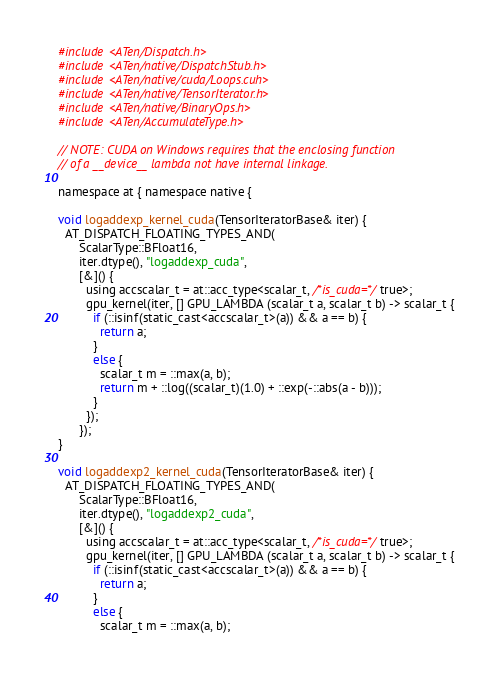<code> <loc_0><loc_0><loc_500><loc_500><_Cuda_>#include <ATen/Dispatch.h>
#include <ATen/native/DispatchStub.h>
#include <ATen/native/cuda/Loops.cuh>
#include <ATen/native/TensorIterator.h>
#include <ATen/native/BinaryOps.h>
#include <ATen/AccumulateType.h>

// NOTE: CUDA on Windows requires that the enclosing function
// of a __device__ lambda not have internal linkage.

namespace at { namespace native {

void logaddexp_kernel_cuda(TensorIteratorBase& iter) {
  AT_DISPATCH_FLOATING_TYPES_AND(
      ScalarType::BFloat16,
      iter.dtype(), "logaddexp_cuda",
      [&]() {
        using accscalar_t = at::acc_type<scalar_t, /*is_cuda=*/true>;
        gpu_kernel(iter, [] GPU_LAMBDA (scalar_t a, scalar_t b) -> scalar_t {
          if (::isinf(static_cast<accscalar_t>(a)) && a == b) {
            return a;
          }
          else {
            scalar_t m = ::max(a, b);
            return m + ::log((scalar_t)(1.0) + ::exp(-::abs(a - b)));
          }
        });
      });
}

void logaddexp2_kernel_cuda(TensorIteratorBase& iter) {
  AT_DISPATCH_FLOATING_TYPES_AND(
      ScalarType::BFloat16,
      iter.dtype(), "logaddexp2_cuda",
      [&]() {
        using accscalar_t = at::acc_type<scalar_t, /*is_cuda=*/true>;
        gpu_kernel(iter, [] GPU_LAMBDA (scalar_t a, scalar_t b) -> scalar_t {
          if (::isinf(static_cast<accscalar_t>(a)) && a == b) {
            return a;
          }
          else {
            scalar_t m = ::max(a, b);</code> 